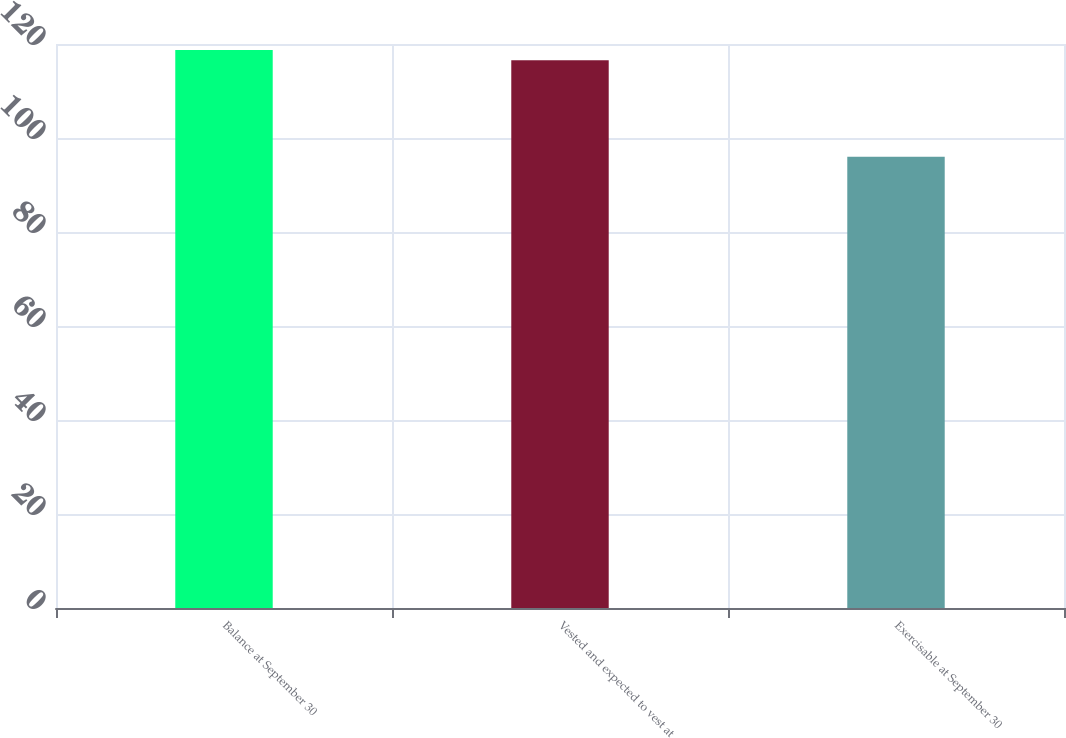Convert chart to OTSL. <chart><loc_0><loc_0><loc_500><loc_500><bar_chart><fcel>Balance at September 30<fcel>Vested and expected to vest at<fcel>Exercisable at September 30<nl><fcel>118.73<fcel>116.54<fcel>96<nl></chart> 